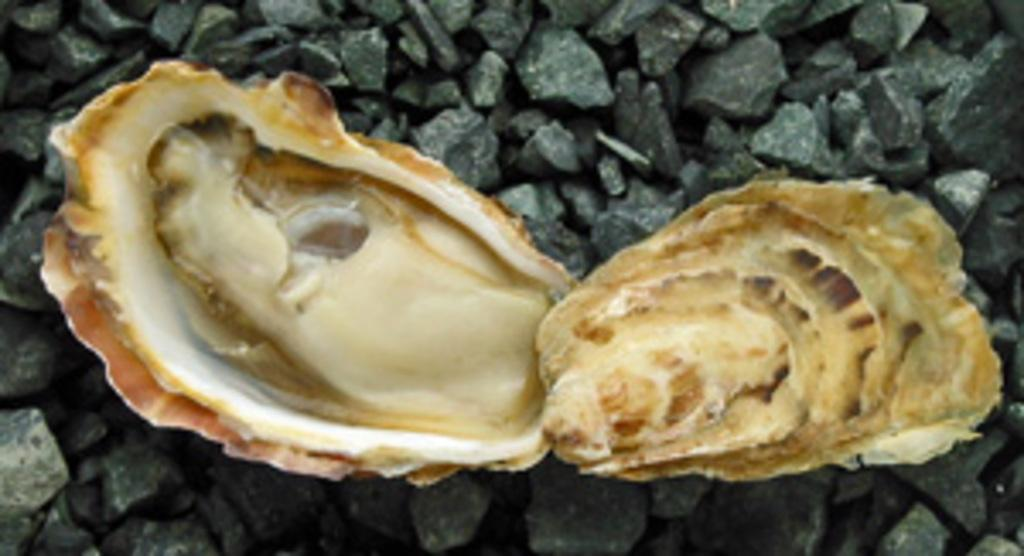What objects can be seen in the image? There are two seashells in the image. Where are the seashells located? The seashells are on stones. What type of judgment is the judge making in the image? There is no judge present in the image, as it only features seashells on stones. 